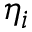Convert formula to latex. <formula><loc_0><loc_0><loc_500><loc_500>\eta _ { i }</formula> 